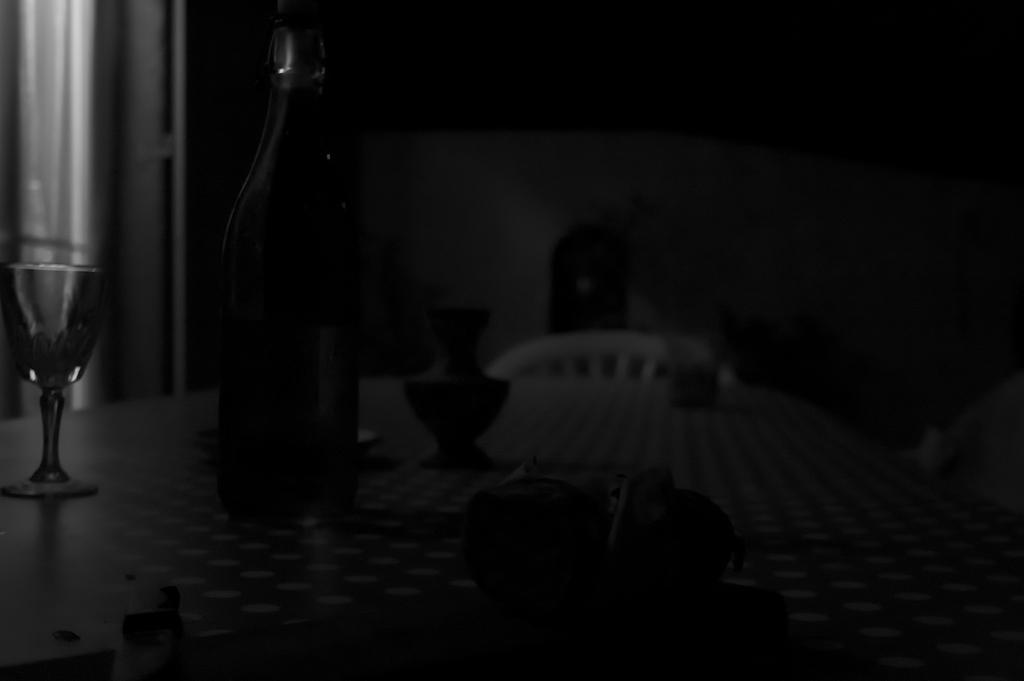Could you give a brief overview of what you see in this image? In this image there is a table and we can see a glass, bottle, vase and some objects placed on the table. In the background there is a chair and a wall. 